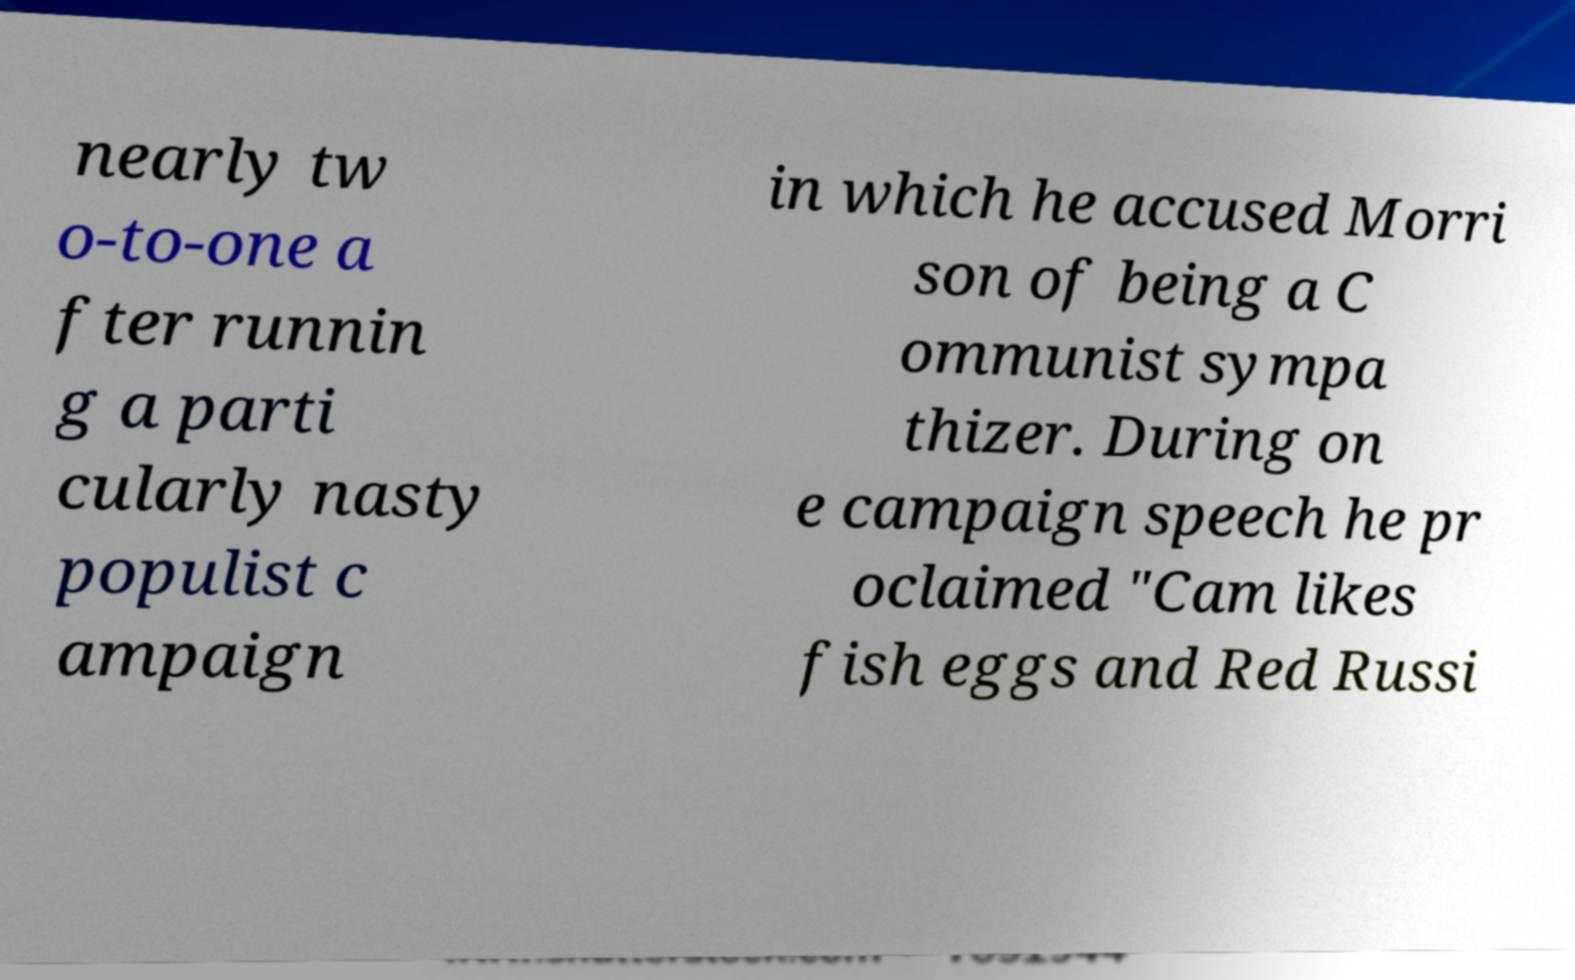Can you read and provide the text displayed in the image?This photo seems to have some interesting text. Can you extract and type it out for me? nearly tw o-to-one a fter runnin g a parti cularly nasty populist c ampaign in which he accused Morri son of being a C ommunist sympa thizer. During on e campaign speech he pr oclaimed "Cam likes fish eggs and Red Russi 